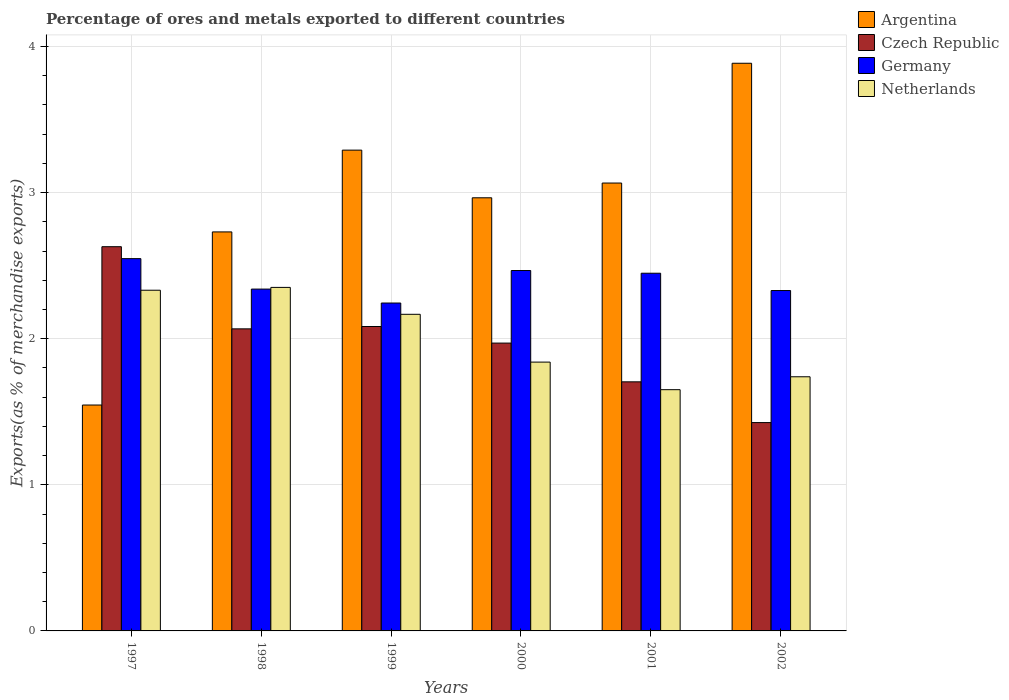How many groups of bars are there?
Give a very brief answer. 6. Are the number of bars on each tick of the X-axis equal?
Offer a very short reply. Yes. How many bars are there on the 5th tick from the right?
Provide a succinct answer. 4. What is the percentage of exports to different countries in Argentina in 2002?
Give a very brief answer. 3.89. Across all years, what is the maximum percentage of exports to different countries in Netherlands?
Your answer should be very brief. 2.35. Across all years, what is the minimum percentage of exports to different countries in Netherlands?
Offer a terse response. 1.65. In which year was the percentage of exports to different countries in Argentina maximum?
Keep it short and to the point. 2002. What is the total percentage of exports to different countries in Netherlands in the graph?
Offer a very short reply. 12.08. What is the difference between the percentage of exports to different countries in Czech Republic in 2000 and that in 2001?
Your response must be concise. 0.27. What is the difference between the percentage of exports to different countries in Argentina in 1997 and the percentage of exports to different countries in Germany in 2002?
Offer a very short reply. -0.78. What is the average percentage of exports to different countries in Argentina per year?
Your answer should be compact. 2.91. In the year 2000, what is the difference between the percentage of exports to different countries in Germany and percentage of exports to different countries in Czech Republic?
Ensure brevity in your answer.  0.5. What is the ratio of the percentage of exports to different countries in Argentina in 1999 to that in 2002?
Provide a short and direct response. 0.85. Is the difference between the percentage of exports to different countries in Germany in 1999 and 2002 greater than the difference between the percentage of exports to different countries in Czech Republic in 1999 and 2002?
Keep it short and to the point. No. What is the difference between the highest and the second highest percentage of exports to different countries in Argentina?
Your answer should be compact. 0.59. What is the difference between the highest and the lowest percentage of exports to different countries in Argentina?
Provide a succinct answer. 2.34. In how many years, is the percentage of exports to different countries in Argentina greater than the average percentage of exports to different countries in Argentina taken over all years?
Offer a terse response. 4. Is the sum of the percentage of exports to different countries in Netherlands in 1999 and 2002 greater than the maximum percentage of exports to different countries in Argentina across all years?
Your response must be concise. Yes. What does the 3rd bar from the left in 1998 represents?
Keep it short and to the point. Germany. What does the 3rd bar from the right in 1999 represents?
Keep it short and to the point. Czech Republic. How many bars are there?
Ensure brevity in your answer.  24. Are the values on the major ticks of Y-axis written in scientific E-notation?
Ensure brevity in your answer.  No. Does the graph contain any zero values?
Keep it short and to the point. No. Does the graph contain grids?
Your response must be concise. Yes. Where does the legend appear in the graph?
Provide a short and direct response. Top right. What is the title of the graph?
Your answer should be compact. Percentage of ores and metals exported to different countries. What is the label or title of the X-axis?
Offer a very short reply. Years. What is the label or title of the Y-axis?
Provide a short and direct response. Exports(as % of merchandise exports). What is the Exports(as % of merchandise exports) of Argentina in 1997?
Your answer should be very brief. 1.55. What is the Exports(as % of merchandise exports) of Czech Republic in 1997?
Give a very brief answer. 2.63. What is the Exports(as % of merchandise exports) in Germany in 1997?
Provide a succinct answer. 2.55. What is the Exports(as % of merchandise exports) in Netherlands in 1997?
Provide a succinct answer. 2.33. What is the Exports(as % of merchandise exports) of Argentina in 1998?
Give a very brief answer. 2.73. What is the Exports(as % of merchandise exports) of Czech Republic in 1998?
Your response must be concise. 2.07. What is the Exports(as % of merchandise exports) of Germany in 1998?
Give a very brief answer. 2.34. What is the Exports(as % of merchandise exports) of Netherlands in 1998?
Keep it short and to the point. 2.35. What is the Exports(as % of merchandise exports) of Argentina in 1999?
Keep it short and to the point. 3.29. What is the Exports(as % of merchandise exports) in Czech Republic in 1999?
Your answer should be compact. 2.08. What is the Exports(as % of merchandise exports) of Germany in 1999?
Give a very brief answer. 2.24. What is the Exports(as % of merchandise exports) of Netherlands in 1999?
Your answer should be very brief. 2.17. What is the Exports(as % of merchandise exports) in Argentina in 2000?
Make the answer very short. 2.96. What is the Exports(as % of merchandise exports) in Czech Republic in 2000?
Make the answer very short. 1.97. What is the Exports(as % of merchandise exports) of Germany in 2000?
Offer a very short reply. 2.47. What is the Exports(as % of merchandise exports) of Netherlands in 2000?
Your response must be concise. 1.84. What is the Exports(as % of merchandise exports) of Argentina in 2001?
Your answer should be compact. 3.07. What is the Exports(as % of merchandise exports) of Czech Republic in 2001?
Your answer should be very brief. 1.7. What is the Exports(as % of merchandise exports) in Germany in 2001?
Ensure brevity in your answer.  2.45. What is the Exports(as % of merchandise exports) in Netherlands in 2001?
Give a very brief answer. 1.65. What is the Exports(as % of merchandise exports) in Argentina in 2002?
Your response must be concise. 3.89. What is the Exports(as % of merchandise exports) in Czech Republic in 2002?
Your answer should be very brief. 1.43. What is the Exports(as % of merchandise exports) of Germany in 2002?
Provide a succinct answer. 2.33. What is the Exports(as % of merchandise exports) in Netherlands in 2002?
Keep it short and to the point. 1.74. Across all years, what is the maximum Exports(as % of merchandise exports) in Argentina?
Provide a succinct answer. 3.89. Across all years, what is the maximum Exports(as % of merchandise exports) of Czech Republic?
Your response must be concise. 2.63. Across all years, what is the maximum Exports(as % of merchandise exports) of Germany?
Provide a short and direct response. 2.55. Across all years, what is the maximum Exports(as % of merchandise exports) of Netherlands?
Provide a short and direct response. 2.35. Across all years, what is the minimum Exports(as % of merchandise exports) in Argentina?
Offer a terse response. 1.55. Across all years, what is the minimum Exports(as % of merchandise exports) of Czech Republic?
Provide a succinct answer. 1.43. Across all years, what is the minimum Exports(as % of merchandise exports) in Germany?
Your answer should be very brief. 2.24. Across all years, what is the minimum Exports(as % of merchandise exports) in Netherlands?
Provide a short and direct response. 1.65. What is the total Exports(as % of merchandise exports) in Argentina in the graph?
Keep it short and to the point. 17.48. What is the total Exports(as % of merchandise exports) of Czech Republic in the graph?
Offer a terse response. 11.88. What is the total Exports(as % of merchandise exports) of Germany in the graph?
Your answer should be compact. 14.38. What is the total Exports(as % of merchandise exports) in Netherlands in the graph?
Make the answer very short. 12.08. What is the difference between the Exports(as % of merchandise exports) in Argentina in 1997 and that in 1998?
Offer a terse response. -1.18. What is the difference between the Exports(as % of merchandise exports) in Czech Republic in 1997 and that in 1998?
Keep it short and to the point. 0.56. What is the difference between the Exports(as % of merchandise exports) of Germany in 1997 and that in 1998?
Your answer should be very brief. 0.21. What is the difference between the Exports(as % of merchandise exports) of Netherlands in 1997 and that in 1998?
Give a very brief answer. -0.02. What is the difference between the Exports(as % of merchandise exports) in Argentina in 1997 and that in 1999?
Make the answer very short. -1.74. What is the difference between the Exports(as % of merchandise exports) in Czech Republic in 1997 and that in 1999?
Your response must be concise. 0.55. What is the difference between the Exports(as % of merchandise exports) of Germany in 1997 and that in 1999?
Your response must be concise. 0.3. What is the difference between the Exports(as % of merchandise exports) of Netherlands in 1997 and that in 1999?
Give a very brief answer. 0.16. What is the difference between the Exports(as % of merchandise exports) of Argentina in 1997 and that in 2000?
Keep it short and to the point. -1.42. What is the difference between the Exports(as % of merchandise exports) of Czech Republic in 1997 and that in 2000?
Your answer should be compact. 0.66. What is the difference between the Exports(as % of merchandise exports) in Germany in 1997 and that in 2000?
Give a very brief answer. 0.08. What is the difference between the Exports(as % of merchandise exports) of Netherlands in 1997 and that in 2000?
Ensure brevity in your answer.  0.49. What is the difference between the Exports(as % of merchandise exports) in Argentina in 1997 and that in 2001?
Give a very brief answer. -1.52. What is the difference between the Exports(as % of merchandise exports) in Czech Republic in 1997 and that in 2001?
Ensure brevity in your answer.  0.92. What is the difference between the Exports(as % of merchandise exports) of Germany in 1997 and that in 2001?
Your answer should be compact. 0.1. What is the difference between the Exports(as % of merchandise exports) of Netherlands in 1997 and that in 2001?
Give a very brief answer. 0.68. What is the difference between the Exports(as % of merchandise exports) of Argentina in 1997 and that in 2002?
Offer a very short reply. -2.34. What is the difference between the Exports(as % of merchandise exports) in Czech Republic in 1997 and that in 2002?
Ensure brevity in your answer.  1.2. What is the difference between the Exports(as % of merchandise exports) of Germany in 1997 and that in 2002?
Make the answer very short. 0.22. What is the difference between the Exports(as % of merchandise exports) in Netherlands in 1997 and that in 2002?
Keep it short and to the point. 0.59. What is the difference between the Exports(as % of merchandise exports) of Argentina in 1998 and that in 1999?
Offer a very short reply. -0.56. What is the difference between the Exports(as % of merchandise exports) in Czech Republic in 1998 and that in 1999?
Your answer should be compact. -0.02. What is the difference between the Exports(as % of merchandise exports) of Germany in 1998 and that in 1999?
Keep it short and to the point. 0.1. What is the difference between the Exports(as % of merchandise exports) of Netherlands in 1998 and that in 1999?
Provide a succinct answer. 0.18. What is the difference between the Exports(as % of merchandise exports) in Argentina in 1998 and that in 2000?
Provide a short and direct response. -0.23. What is the difference between the Exports(as % of merchandise exports) of Czech Republic in 1998 and that in 2000?
Your answer should be compact. 0.1. What is the difference between the Exports(as % of merchandise exports) in Germany in 1998 and that in 2000?
Provide a succinct answer. -0.13. What is the difference between the Exports(as % of merchandise exports) in Netherlands in 1998 and that in 2000?
Offer a terse response. 0.51. What is the difference between the Exports(as % of merchandise exports) of Argentina in 1998 and that in 2001?
Ensure brevity in your answer.  -0.33. What is the difference between the Exports(as % of merchandise exports) of Czech Republic in 1998 and that in 2001?
Provide a short and direct response. 0.36. What is the difference between the Exports(as % of merchandise exports) in Germany in 1998 and that in 2001?
Ensure brevity in your answer.  -0.11. What is the difference between the Exports(as % of merchandise exports) of Netherlands in 1998 and that in 2001?
Provide a short and direct response. 0.7. What is the difference between the Exports(as % of merchandise exports) in Argentina in 1998 and that in 2002?
Keep it short and to the point. -1.15. What is the difference between the Exports(as % of merchandise exports) in Czech Republic in 1998 and that in 2002?
Ensure brevity in your answer.  0.64. What is the difference between the Exports(as % of merchandise exports) of Germany in 1998 and that in 2002?
Keep it short and to the point. 0.01. What is the difference between the Exports(as % of merchandise exports) in Netherlands in 1998 and that in 2002?
Provide a succinct answer. 0.61. What is the difference between the Exports(as % of merchandise exports) of Argentina in 1999 and that in 2000?
Provide a short and direct response. 0.33. What is the difference between the Exports(as % of merchandise exports) in Czech Republic in 1999 and that in 2000?
Ensure brevity in your answer.  0.11. What is the difference between the Exports(as % of merchandise exports) in Germany in 1999 and that in 2000?
Offer a terse response. -0.22. What is the difference between the Exports(as % of merchandise exports) of Netherlands in 1999 and that in 2000?
Your response must be concise. 0.33. What is the difference between the Exports(as % of merchandise exports) in Argentina in 1999 and that in 2001?
Offer a very short reply. 0.23. What is the difference between the Exports(as % of merchandise exports) in Czech Republic in 1999 and that in 2001?
Give a very brief answer. 0.38. What is the difference between the Exports(as % of merchandise exports) of Germany in 1999 and that in 2001?
Give a very brief answer. -0.2. What is the difference between the Exports(as % of merchandise exports) in Netherlands in 1999 and that in 2001?
Provide a short and direct response. 0.52. What is the difference between the Exports(as % of merchandise exports) in Argentina in 1999 and that in 2002?
Give a very brief answer. -0.59. What is the difference between the Exports(as % of merchandise exports) of Czech Republic in 1999 and that in 2002?
Offer a very short reply. 0.66. What is the difference between the Exports(as % of merchandise exports) of Germany in 1999 and that in 2002?
Your answer should be compact. -0.09. What is the difference between the Exports(as % of merchandise exports) of Netherlands in 1999 and that in 2002?
Keep it short and to the point. 0.43. What is the difference between the Exports(as % of merchandise exports) in Argentina in 2000 and that in 2001?
Your answer should be very brief. -0.1. What is the difference between the Exports(as % of merchandise exports) of Czech Republic in 2000 and that in 2001?
Ensure brevity in your answer.  0.27. What is the difference between the Exports(as % of merchandise exports) of Germany in 2000 and that in 2001?
Ensure brevity in your answer.  0.02. What is the difference between the Exports(as % of merchandise exports) of Netherlands in 2000 and that in 2001?
Offer a very short reply. 0.19. What is the difference between the Exports(as % of merchandise exports) of Argentina in 2000 and that in 2002?
Ensure brevity in your answer.  -0.92. What is the difference between the Exports(as % of merchandise exports) of Czech Republic in 2000 and that in 2002?
Give a very brief answer. 0.54. What is the difference between the Exports(as % of merchandise exports) in Germany in 2000 and that in 2002?
Keep it short and to the point. 0.14. What is the difference between the Exports(as % of merchandise exports) of Netherlands in 2000 and that in 2002?
Give a very brief answer. 0.1. What is the difference between the Exports(as % of merchandise exports) of Argentina in 2001 and that in 2002?
Your answer should be very brief. -0.82. What is the difference between the Exports(as % of merchandise exports) in Czech Republic in 2001 and that in 2002?
Your answer should be very brief. 0.28. What is the difference between the Exports(as % of merchandise exports) in Germany in 2001 and that in 2002?
Provide a short and direct response. 0.12. What is the difference between the Exports(as % of merchandise exports) of Netherlands in 2001 and that in 2002?
Make the answer very short. -0.09. What is the difference between the Exports(as % of merchandise exports) of Argentina in 1997 and the Exports(as % of merchandise exports) of Czech Republic in 1998?
Your answer should be very brief. -0.52. What is the difference between the Exports(as % of merchandise exports) in Argentina in 1997 and the Exports(as % of merchandise exports) in Germany in 1998?
Ensure brevity in your answer.  -0.79. What is the difference between the Exports(as % of merchandise exports) of Argentina in 1997 and the Exports(as % of merchandise exports) of Netherlands in 1998?
Give a very brief answer. -0.81. What is the difference between the Exports(as % of merchandise exports) in Czech Republic in 1997 and the Exports(as % of merchandise exports) in Germany in 1998?
Ensure brevity in your answer.  0.29. What is the difference between the Exports(as % of merchandise exports) of Czech Republic in 1997 and the Exports(as % of merchandise exports) of Netherlands in 1998?
Provide a short and direct response. 0.28. What is the difference between the Exports(as % of merchandise exports) in Germany in 1997 and the Exports(as % of merchandise exports) in Netherlands in 1998?
Your answer should be very brief. 0.2. What is the difference between the Exports(as % of merchandise exports) of Argentina in 1997 and the Exports(as % of merchandise exports) of Czech Republic in 1999?
Provide a short and direct response. -0.54. What is the difference between the Exports(as % of merchandise exports) in Argentina in 1997 and the Exports(as % of merchandise exports) in Germany in 1999?
Give a very brief answer. -0.7. What is the difference between the Exports(as % of merchandise exports) of Argentina in 1997 and the Exports(as % of merchandise exports) of Netherlands in 1999?
Offer a terse response. -0.62. What is the difference between the Exports(as % of merchandise exports) of Czech Republic in 1997 and the Exports(as % of merchandise exports) of Germany in 1999?
Provide a succinct answer. 0.39. What is the difference between the Exports(as % of merchandise exports) of Czech Republic in 1997 and the Exports(as % of merchandise exports) of Netherlands in 1999?
Keep it short and to the point. 0.46. What is the difference between the Exports(as % of merchandise exports) of Germany in 1997 and the Exports(as % of merchandise exports) of Netherlands in 1999?
Your answer should be very brief. 0.38. What is the difference between the Exports(as % of merchandise exports) of Argentina in 1997 and the Exports(as % of merchandise exports) of Czech Republic in 2000?
Provide a succinct answer. -0.42. What is the difference between the Exports(as % of merchandise exports) of Argentina in 1997 and the Exports(as % of merchandise exports) of Germany in 2000?
Your response must be concise. -0.92. What is the difference between the Exports(as % of merchandise exports) in Argentina in 1997 and the Exports(as % of merchandise exports) in Netherlands in 2000?
Ensure brevity in your answer.  -0.29. What is the difference between the Exports(as % of merchandise exports) in Czech Republic in 1997 and the Exports(as % of merchandise exports) in Germany in 2000?
Your answer should be very brief. 0.16. What is the difference between the Exports(as % of merchandise exports) in Czech Republic in 1997 and the Exports(as % of merchandise exports) in Netherlands in 2000?
Provide a short and direct response. 0.79. What is the difference between the Exports(as % of merchandise exports) of Germany in 1997 and the Exports(as % of merchandise exports) of Netherlands in 2000?
Keep it short and to the point. 0.71. What is the difference between the Exports(as % of merchandise exports) in Argentina in 1997 and the Exports(as % of merchandise exports) in Czech Republic in 2001?
Provide a short and direct response. -0.16. What is the difference between the Exports(as % of merchandise exports) in Argentina in 1997 and the Exports(as % of merchandise exports) in Germany in 2001?
Give a very brief answer. -0.9. What is the difference between the Exports(as % of merchandise exports) in Argentina in 1997 and the Exports(as % of merchandise exports) in Netherlands in 2001?
Offer a terse response. -0.1. What is the difference between the Exports(as % of merchandise exports) of Czech Republic in 1997 and the Exports(as % of merchandise exports) of Germany in 2001?
Ensure brevity in your answer.  0.18. What is the difference between the Exports(as % of merchandise exports) of Czech Republic in 1997 and the Exports(as % of merchandise exports) of Netherlands in 2001?
Provide a short and direct response. 0.98. What is the difference between the Exports(as % of merchandise exports) in Germany in 1997 and the Exports(as % of merchandise exports) in Netherlands in 2001?
Your answer should be compact. 0.9. What is the difference between the Exports(as % of merchandise exports) of Argentina in 1997 and the Exports(as % of merchandise exports) of Czech Republic in 2002?
Your answer should be very brief. 0.12. What is the difference between the Exports(as % of merchandise exports) of Argentina in 1997 and the Exports(as % of merchandise exports) of Germany in 2002?
Provide a succinct answer. -0.78. What is the difference between the Exports(as % of merchandise exports) of Argentina in 1997 and the Exports(as % of merchandise exports) of Netherlands in 2002?
Keep it short and to the point. -0.19. What is the difference between the Exports(as % of merchandise exports) in Czech Republic in 1997 and the Exports(as % of merchandise exports) in Germany in 2002?
Your response must be concise. 0.3. What is the difference between the Exports(as % of merchandise exports) of Czech Republic in 1997 and the Exports(as % of merchandise exports) of Netherlands in 2002?
Ensure brevity in your answer.  0.89. What is the difference between the Exports(as % of merchandise exports) in Germany in 1997 and the Exports(as % of merchandise exports) in Netherlands in 2002?
Your response must be concise. 0.81. What is the difference between the Exports(as % of merchandise exports) in Argentina in 1998 and the Exports(as % of merchandise exports) in Czech Republic in 1999?
Offer a terse response. 0.65. What is the difference between the Exports(as % of merchandise exports) of Argentina in 1998 and the Exports(as % of merchandise exports) of Germany in 1999?
Keep it short and to the point. 0.49. What is the difference between the Exports(as % of merchandise exports) in Argentina in 1998 and the Exports(as % of merchandise exports) in Netherlands in 1999?
Your answer should be compact. 0.56. What is the difference between the Exports(as % of merchandise exports) of Czech Republic in 1998 and the Exports(as % of merchandise exports) of Germany in 1999?
Make the answer very short. -0.18. What is the difference between the Exports(as % of merchandise exports) in Czech Republic in 1998 and the Exports(as % of merchandise exports) in Netherlands in 1999?
Give a very brief answer. -0.1. What is the difference between the Exports(as % of merchandise exports) in Germany in 1998 and the Exports(as % of merchandise exports) in Netherlands in 1999?
Offer a very short reply. 0.17. What is the difference between the Exports(as % of merchandise exports) of Argentina in 1998 and the Exports(as % of merchandise exports) of Czech Republic in 2000?
Make the answer very short. 0.76. What is the difference between the Exports(as % of merchandise exports) of Argentina in 1998 and the Exports(as % of merchandise exports) of Germany in 2000?
Make the answer very short. 0.26. What is the difference between the Exports(as % of merchandise exports) in Argentina in 1998 and the Exports(as % of merchandise exports) in Netherlands in 2000?
Offer a very short reply. 0.89. What is the difference between the Exports(as % of merchandise exports) of Czech Republic in 1998 and the Exports(as % of merchandise exports) of Germany in 2000?
Offer a terse response. -0.4. What is the difference between the Exports(as % of merchandise exports) in Czech Republic in 1998 and the Exports(as % of merchandise exports) in Netherlands in 2000?
Offer a very short reply. 0.23. What is the difference between the Exports(as % of merchandise exports) of Germany in 1998 and the Exports(as % of merchandise exports) of Netherlands in 2000?
Keep it short and to the point. 0.5. What is the difference between the Exports(as % of merchandise exports) in Argentina in 1998 and the Exports(as % of merchandise exports) in Czech Republic in 2001?
Ensure brevity in your answer.  1.03. What is the difference between the Exports(as % of merchandise exports) of Argentina in 1998 and the Exports(as % of merchandise exports) of Germany in 2001?
Ensure brevity in your answer.  0.28. What is the difference between the Exports(as % of merchandise exports) in Argentina in 1998 and the Exports(as % of merchandise exports) in Netherlands in 2001?
Keep it short and to the point. 1.08. What is the difference between the Exports(as % of merchandise exports) in Czech Republic in 1998 and the Exports(as % of merchandise exports) in Germany in 2001?
Make the answer very short. -0.38. What is the difference between the Exports(as % of merchandise exports) of Czech Republic in 1998 and the Exports(as % of merchandise exports) of Netherlands in 2001?
Offer a very short reply. 0.42. What is the difference between the Exports(as % of merchandise exports) in Germany in 1998 and the Exports(as % of merchandise exports) in Netherlands in 2001?
Make the answer very short. 0.69. What is the difference between the Exports(as % of merchandise exports) of Argentina in 1998 and the Exports(as % of merchandise exports) of Czech Republic in 2002?
Your response must be concise. 1.31. What is the difference between the Exports(as % of merchandise exports) of Argentina in 1998 and the Exports(as % of merchandise exports) of Germany in 2002?
Ensure brevity in your answer.  0.4. What is the difference between the Exports(as % of merchandise exports) of Argentina in 1998 and the Exports(as % of merchandise exports) of Netherlands in 2002?
Your answer should be compact. 0.99. What is the difference between the Exports(as % of merchandise exports) in Czech Republic in 1998 and the Exports(as % of merchandise exports) in Germany in 2002?
Ensure brevity in your answer.  -0.26. What is the difference between the Exports(as % of merchandise exports) of Czech Republic in 1998 and the Exports(as % of merchandise exports) of Netherlands in 2002?
Offer a terse response. 0.33. What is the difference between the Exports(as % of merchandise exports) of Germany in 1998 and the Exports(as % of merchandise exports) of Netherlands in 2002?
Offer a very short reply. 0.6. What is the difference between the Exports(as % of merchandise exports) in Argentina in 1999 and the Exports(as % of merchandise exports) in Czech Republic in 2000?
Make the answer very short. 1.32. What is the difference between the Exports(as % of merchandise exports) in Argentina in 1999 and the Exports(as % of merchandise exports) in Germany in 2000?
Ensure brevity in your answer.  0.82. What is the difference between the Exports(as % of merchandise exports) in Argentina in 1999 and the Exports(as % of merchandise exports) in Netherlands in 2000?
Keep it short and to the point. 1.45. What is the difference between the Exports(as % of merchandise exports) of Czech Republic in 1999 and the Exports(as % of merchandise exports) of Germany in 2000?
Offer a very short reply. -0.38. What is the difference between the Exports(as % of merchandise exports) of Czech Republic in 1999 and the Exports(as % of merchandise exports) of Netherlands in 2000?
Provide a succinct answer. 0.24. What is the difference between the Exports(as % of merchandise exports) of Germany in 1999 and the Exports(as % of merchandise exports) of Netherlands in 2000?
Make the answer very short. 0.4. What is the difference between the Exports(as % of merchandise exports) of Argentina in 1999 and the Exports(as % of merchandise exports) of Czech Republic in 2001?
Offer a very short reply. 1.59. What is the difference between the Exports(as % of merchandise exports) in Argentina in 1999 and the Exports(as % of merchandise exports) in Germany in 2001?
Keep it short and to the point. 0.84. What is the difference between the Exports(as % of merchandise exports) of Argentina in 1999 and the Exports(as % of merchandise exports) of Netherlands in 2001?
Offer a very short reply. 1.64. What is the difference between the Exports(as % of merchandise exports) in Czech Republic in 1999 and the Exports(as % of merchandise exports) in Germany in 2001?
Offer a terse response. -0.36. What is the difference between the Exports(as % of merchandise exports) of Czech Republic in 1999 and the Exports(as % of merchandise exports) of Netherlands in 2001?
Provide a short and direct response. 0.43. What is the difference between the Exports(as % of merchandise exports) in Germany in 1999 and the Exports(as % of merchandise exports) in Netherlands in 2001?
Your answer should be very brief. 0.59. What is the difference between the Exports(as % of merchandise exports) of Argentina in 1999 and the Exports(as % of merchandise exports) of Czech Republic in 2002?
Give a very brief answer. 1.86. What is the difference between the Exports(as % of merchandise exports) in Argentina in 1999 and the Exports(as % of merchandise exports) in Germany in 2002?
Your response must be concise. 0.96. What is the difference between the Exports(as % of merchandise exports) of Argentina in 1999 and the Exports(as % of merchandise exports) of Netherlands in 2002?
Your answer should be compact. 1.55. What is the difference between the Exports(as % of merchandise exports) of Czech Republic in 1999 and the Exports(as % of merchandise exports) of Germany in 2002?
Offer a terse response. -0.25. What is the difference between the Exports(as % of merchandise exports) in Czech Republic in 1999 and the Exports(as % of merchandise exports) in Netherlands in 2002?
Your response must be concise. 0.34. What is the difference between the Exports(as % of merchandise exports) of Germany in 1999 and the Exports(as % of merchandise exports) of Netherlands in 2002?
Offer a very short reply. 0.5. What is the difference between the Exports(as % of merchandise exports) in Argentina in 2000 and the Exports(as % of merchandise exports) in Czech Republic in 2001?
Ensure brevity in your answer.  1.26. What is the difference between the Exports(as % of merchandise exports) in Argentina in 2000 and the Exports(as % of merchandise exports) in Germany in 2001?
Provide a succinct answer. 0.52. What is the difference between the Exports(as % of merchandise exports) of Argentina in 2000 and the Exports(as % of merchandise exports) of Netherlands in 2001?
Provide a succinct answer. 1.31. What is the difference between the Exports(as % of merchandise exports) in Czech Republic in 2000 and the Exports(as % of merchandise exports) in Germany in 2001?
Make the answer very short. -0.48. What is the difference between the Exports(as % of merchandise exports) of Czech Republic in 2000 and the Exports(as % of merchandise exports) of Netherlands in 2001?
Your answer should be very brief. 0.32. What is the difference between the Exports(as % of merchandise exports) in Germany in 2000 and the Exports(as % of merchandise exports) in Netherlands in 2001?
Your answer should be very brief. 0.82. What is the difference between the Exports(as % of merchandise exports) of Argentina in 2000 and the Exports(as % of merchandise exports) of Czech Republic in 2002?
Provide a succinct answer. 1.54. What is the difference between the Exports(as % of merchandise exports) of Argentina in 2000 and the Exports(as % of merchandise exports) of Germany in 2002?
Your response must be concise. 0.63. What is the difference between the Exports(as % of merchandise exports) of Argentina in 2000 and the Exports(as % of merchandise exports) of Netherlands in 2002?
Offer a very short reply. 1.23. What is the difference between the Exports(as % of merchandise exports) of Czech Republic in 2000 and the Exports(as % of merchandise exports) of Germany in 2002?
Your answer should be compact. -0.36. What is the difference between the Exports(as % of merchandise exports) in Czech Republic in 2000 and the Exports(as % of merchandise exports) in Netherlands in 2002?
Make the answer very short. 0.23. What is the difference between the Exports(as % of merchandise exports) of Germany in 2000 and the Exports(as % of merchandise exports) of Netherlands in 2002?
Ensure brevity in your answer.  0.73. What is the difference between the Exports(as % of merchandise exports) in Argentina in 2001 and the Exports(as % of merchandise exports) in Czech Republic in 2002?
Make the answer very short. 1.64. What is the difference between the Exports(as % of merchandise exports) of Argentina in 2001 and the Exports(as % of merchandise exports) of Germany in 2002?
Make the answer very short. 0.74. What is the difference between the Exports(as % of merchandise exports) in Argentina in 2001 and the Exports(as % of merchandise exports) in Netherlands in 2002?
Ensure brevity in your answer.  1.33. What is the difference between the Exports(as % of merchandise exports) of Czech Republic in 2001 and the Exports(as % of merchandise exports) of Germany in 2002?
Give a very brief answer. -0.62. What is the difference between the Exports(as % of merchandise exports) of Czech Republic in 2001 and the Exports(as % of merchandise exports) of Netherlands in 2002?
Offer a very short reply. -0.03. What is the difference between the Exports(as % of merchandise exports) in Germany in 2001 and the Exports(as % of merchandise exports) in Netherlands in 2002?
Give a very brief answer. 0.71. What is the average Exports(as % of merchandise exports) in Argentina per year?
Your response must be concise. 2.91. What is the average Exports(as % of merchandise exports) of Czech Republic per year?
Your response must be concise. 1.98. What is the average Exports(as % of merchandise exports) of Germany per year?
Keep it short and to the point. 2.4. What is the average Exports(as % of merchandise exports) of Netherlands per year?
Your answer should be compact. 2.01. In the year 1997, what is the difference between the Exports(as % of merchandise exports) in Argentina and Exports(as % of merchandise exports) in Czech Republic?
Offer a terse response. -1.08. In the year 1997, what is the difference between the Exports(as % of merchandise exports) in Argentina and Exports(as % of merchandise exports) in Germany?
Keep it short and to the point. -1. In the year 1997, what is the difference between the Exports(as % of merchandise exports) of Argentina and Exports(as % of merchandise exports) of Netherlands?
Make the answer very short. -0.79. In the year 1997, what is the difference between the Exports(as % of merchandise exports) in Czech Republic and Exports(as % of merchandise exports) in Germany?
Ensure brevity in your answer.  0.08. In the year 1997, what is the difference between the Exports(as % of merchandise exports) in Czech Republic and Exports(as % of merchandise exports) in Netherlands?
Your response must be concise. 0.3. In the year 1997, what is the difference between the Exports(as % of merchandise exports) in Germany and Exports(as % of merchandise exports) in Netherlands?
Offer a very short reply. 0.22. In the year 1998, what is the difference between the Exports(as % of merchandise exports) of Argentina and Exports(as % of merchandise exports) of Czech Republic?
Give a very brief answer. 0.66. In the year 1998, what is the difference between the Exports(as % of merchandise exports) of Argentina and Exports(as % of merchandise exports) of Germany?
Provide a short and direct response. 0.39. In the year 1998, what is the difference between the Exports(as % of merchandise exports) of Argentina and Exports(as % of merchandise exports) of Netherlands?
Ensure brevity in your answer.  0.38. In the year 1998, what is the difference between the Exports(as % of merchandise exports) in Czech Republic and Exports(as % of merchandise exports) in Germany?
Keep it short and to the point. -0.27. In the year 1998, what is the difference between the Exports(as % of merchandise exports) in Czech Republic and Exports(as % of merchandise exports) in Netherlands?
Your answer should be very brief. -0.28. In the year 1998, what is the difference between the Exports(as % of merchandise exports) of Germany and Exports(as % of merchandise exports) of Netherlands?
Make the answer very short. -0.01. In the year 1999, what is the difference between the Exports(as % of merchandise exports) of Argentina and Exports(as % of merchandise exports) of Czech Republic?
Your answer should be compact. 1.21. In the year 1999, what is the difference between the Exports(as % of merchandise exports) in Argentina and Exports(as % of merchandise exports) in Germany?
Your answer should be compact. 1.05. In the year 1999, what is the difference between the Exports(as % of merchandise exports) in Argentina and Exports(as % of merchandise exports) in Netherlands?
Ensure brevity in your answer.  1.12. In the year 1999, what is the difference between the Exports(as % of merchandise exports) in Czech Republic and Exports(as % of merchandise exports) in Germany?
Provide a short and direct response. -0.16. In the year 1999, what is the difference between the Exports(as % of merchandise exports) in Czech Republic and Exports(as % of merchandise exports) in Netherlands?
Make the answer very short. -0.08. In the year 1999, what is the difference between the Exports(as % of merchandise exports) in Germany and Exports(as % of merchandise exports) in Netherlands?
Your answer should be very brief. 0.08. In the year 2000, what is the difference between the Exports(as % of merchandise exports) in Argentina and Exports(as % of merchandise exports) in Germany?
Your answer should be compact. 0.5. In the year 2000, what is the difference between the Exports(as % of merchandise exports) in Argentina and Exports(as % of merchandise exports) in Netherlands?
Provide a short and direct response. 1.12. In the year 2000, what is the difference between the Exports(as % of merchandise exports) of Czech Republic and Exports(as % of merchandise exports) of Germany?
Make the answer very short. -0.5. In the year 2000, what is the difference between the Exports(as % of merchandise exports) in Czech Republic and Exports(as % of merchandise exports) in Netherlands?
Give a very brief answer. 0.13. In the year 2000, what is the difference between the Exports(as % of merchandise exports) of Germany and Exports(as % of merchandise exports) of Netherlands?
Offer a terse response. 0.63. In the year 2001, what is the difference between the Exports(as % of merchandise exports) in Argentina and Exports(as % of merchandise exports) in Czech Republic?
Provide a succinct answer. 1.36. In the year 2001, what is the difference between the Exports(as % of merchandise exports) in Argentina and Exports(as % of merchandise exports) in Germany?
Offer a very short reply. 0.62. In the year 2001, what is the difference between the Exports(as % of merchandise exports) of Argentina and Exports(as % of merchandise exports) of Netherlands?
Make the answer very short. 1.41. In the year 2001, what is the difference between the Exports(as % of merchandise exports) of Czech Republic and Exports(as % of merchandise exports) of Germany?
Give a very brief answer. -0.74. In the year 2001, what is the difference between the Exports(as % of merchandise exports) in Czech Republic and Exports(as % of merchandise exports) in Netherlands?
Ensure brevity in your answer.  0.05. In the year 2001, what is the difference between the Exports(as % of merchandise exports) in Germany and Exports(as % of merchandise exports) in Netherlands?
Offer a very short reply. 0.8. In the year 2002, what is the difference between the Exports(as % of merchandise exports) in Argentina and Exports(as % of merchandise exports) in Czech Republic?
Offer a very short reply. 2.46. In the year 2002, what is the difference between the Exports(as % of merchandise exports) of Argentina and Exports(as % of merchandise exports) of Germany?
Your answer should be compact. 1.56. In the year 2002, what is the difference between the Exports(as % of merchandise exports) of Argentina and Exports(as % of merchandise exports) of Netherlands?
Make the answer very short. 2.15. In the year 2002, what is the difference between the Exports(as % of merchandise exports) of Czech Republic and Exports(as % of merchandise exports) of Germany?
Give a very brief answer. -0.9. In the year 2002, what is the difference between the Exports(as % of merchandise exports) in Czech Republic and Exports(as % of merchandise exports) in Netherlands?
Give a very brief answer. -0.31. In the year 2002, what is the difference between the Exports(as % of merchandise exports) of Germany and Exports(as % of merchandise exports) of Netherlands?
Offer a terse response. 0.59. What is the ratio of the Exports(as % of merchandise exports) of Argentina in 1997 to that in 1998?
Ensure brevity in your answer.  0.57. What is the ratio of the Exports(as % of merchandise exports) of Czech Republic in 1997 to that in 1998?
Give a very brief answer. 1.27. What is the ratio of the Exports(as % of merchandise exports) of Germany in 1997 to that in 1998?
Provide a short and direct response. 1.09. What is the ratio of the Exports(as % of merchandise exports) of Netherlands in 1997 to that in 1998?
Provide a short and direct response. 0.99. What is the ratio of the Exports(as % of merchandise exports) of Argentina in 1997 to that in 1999?
Your answer should be compact. 0.47. What is the ratio of the Exports(as % of merchandise exports) in Czech Republic in 1997 to that in 1999?
Provide a succinct answer. 1.26. What is the ratio of the Exports(as % of merchandise exports) of Germany in 1997 to that in 1999?
Offer a very short reply. 1.14. What is the ratio of the Exports(as % of merchandise exports) of Netherlands in 1997 to that in 1999?
Ensure brevity in your answer.  1.08. What is the ratio of the Exports(as % of merchandise exports) in Argentina in 1997 to that in 2000?
Your answer should be very brief. 0.52. What is the ratio of the Exports(as % of merchandise exports) of Czech Republic in 1997 to that in 2000?
Give a very brief answer. 1.33. What is the ratio of the Exports(as % of merchandise exports) in Germany in 1997 to that in 2000?
Provide a succinct answer. 1.03. What is the ratio of the Exports(as % of merchandise exports) of Netherlands in 1997 to that in 2000?
Your response must be concise. 1.27. What is the ratio of the Exports(as % of merchandise exports) of Argentina in 1997 to that in 2001?
Provide a short and direct response. 0.5. What is the ratio of the Exports(as % of merchandise exports) in Czech Republic in 1997 to that in 2001?
Your answer should be very brief. 1.54. What is the ratio of the Exports(as % of merchandise exports) in Germany in 1997 to that in 2001?
Make the answer very short. 1.04. What is the ratio of the Exports(as % of merchandise exports) of Netherlands in 1997 to that in 2001?
Your answer should be compact. 1.41. What is the ratio of the Exports(as % of merchandise exports) of Argentina in 1997 to that in 2002?
Make the answer very short. 0.4. What is the ratio of the Exports(as % of merchandise exports) of Czech Republic in 1997 to that in 2002?
Offer a terse response. 1.84. What is the ratio of the Exports(as % of merchandise exports) in Germany in 1997 to that in 2002?
Provide a succinct answer. 1.09. What is the ratio of the Exports(as % of merchandise exports) of Netherlands in 1997 to that in 2002?
Your response must be concise. 1.34. What is the ratio of the Exports(as % of merchandise exports) of Argentina in 1998 to that in 1999?
Offer a terse response. 0.83. What is the ratio of the Exports(as % of merchandise exports) of Germany in 1998 to that in 1999?
Make the answer very short. 1.04. What is the ratio of the Exports(as % of merchandise exports) of Netherlands in 1998 to that in 1999?
Offer a very short reply. 1.08. What is the ratio of the Exports(as % of merchandise exports) in Argentina in 1998 to that in 2000?
Make the answer very short. 0.92. What is the ratio of the Exports(as % of merchandise exports) in Czech Republic in 1998 to that in 2000?
Give a very brief answer. 1.05. What is the ratio of the Exports(as % of merchandise exports) in Germany in 1998 to that in 2000?
Your answer should be compact. 0.95. What is the ratio of the Exports(as % of merchandise exports) in Netherlands in 1998 to that in 2000?
Offer a terse response. 1.28. What is the ratio of the Exports(as % of merchandise exports) in Argentina in 1998 to that in 2001?
Your answer should be very brief. 0.89. What is the ratio of the Exports(as % of merchandise exports) in Czech Republic in 1998 to that in 2001?
Offer a very short reply. 1.21. What is the ratio of the Exports(as % of merchandise exports) in Germany in 1998 to that in 2001?
Make the answer very short. 0.96. What is the ratio of the Exports(as % of merchandise exports) in Netherlands in 1998 to that in 2001?
Provide a short and direct response. 1.42. What is the ratio of the Exports(as % of merchandise exports) in Argentina in 1998 to that in 2002?
Give a very brief answer. 0.7. What is the ratio of the Exports(as % of merchandise exports) of Czech Republic in 1998 to that in 2002?
Your answer should be compact. 1.45. What is the ratio of the Exports(as % of merchandise exports) in Germany in 1998 to that in 2002?
Your response must be concise. 1. What is the ratio of the Exports(as % of merchandise exports) of Netherlands in 1998 to that in 2002?
Offer a very short reply. 1.35. What is the ratio of the Exports(as % of merchandise exports) in Argentina in 1999 to that in 2000?
Your answer should be very brief. 1.11. What is the ratio of the Exports(as % of merchandise exports) of Czech Republic in 1999 to that in 2000?
Ensure brevity in your answer.  1.06. What is the ratio of the Exports(as % of merchandise exports) of Germany in 1999 to that in 2000?
Provide a succinct answer. 0.91. What is the ratio of the Exports(as % of merchandise exports) in Netherlands in 1999 to that in 2000?
Keep it short and to the point. 1.18. What is the ratio of the Exports(as % of merchandise exports) in Argentina in 1999 to that in 2001?
Your response must be concise. 1.07. What is the ratio of the Exports(as % of merchandise exports) of Czech Republic in 1999 to that in 2001?
Offer a very short reply. 1.22. What is the ratio of the Exports(as % of merchandise exports) in Germany in 1999 to that in 2001?
Your response must be concise. 0.92. What is the ratio of the Exports(as % of merchandise exports) of Netherlands in 1999 to that in 2001?
Provide a succinct answer. 1.31. What is the ratio of the Exports(as % of merchandise exports) of Argentina in 1999 to that in 2002?
Provide a short and direct response. 0.85. What is the ratio of the Exports(as % of merchandise exports) in Czech Republic in 1999 to that in 2002?
Provide a succinct answer. 1.46. What is the ratio of the Exports(as % of merchandise exports) in Germany in 1999 to that in 2002?
Make the answer very short. 0.96. What is the ratio of the Exports(as % of merchandise exports) of Netherlands in 1999 to that in 2002?
Ensure brevity in your answer.  1.25. What is the ratio of the Exports(as % of merchandise exports) of Argentina in 2000 to that in 2001?
Keep it short and to the point. 0.97. What is the ratio of the Exports(as % of merchandise exports) in Czech Republic in 2000 to that in 2001?
Your answer should be compact. 1.16. What is the ratio of the Exports(as % of merchandise exports) of Germany in 2000 to that in 2001?
Your response must be concise. 1.01. What is the ratio of the Exports(as % of merchandise exports) in Netherlands in 2000 to that in 2001?
Make the answer very short. 1.11. What is the ratio of the Exports(as % of merchandise exports) of Argentina in 2000 to that in 2002?
Offer a terse response. 0.76. What is the ratio of the Exports(as % of merchandise exports) of Czech Republic in 2000 to that in 2002?
Provide a succinct answer. 1.38. What is the ratio of the Exports(as % of merchandise exports) of Germany in 2000 to that in 2002?
Provide a succinct answer. 1.06. What is the ratio of the Exports(as % of merchandise exports) of Netherlands in 2000 to that in 2002?
Give a very brief answer. 1.06. What is the ratio of the Exports(as % of merchandise exports) in Argentina in 2001 to that in 2002?
Provide a succinct answer. 0.79. What is the ratio of the Exports(as % of merchandise exports) in Czech Republic in 2001 to that in 2002?
Offer a very short reply. 1.2. What is the ratio of the Exports(as % of merchandise exports) of Germany in 2001 to that in 2002?
Your answer should be compact. 1.05. What is the ratio of the Exports(as % of merchandise exports) in Netherlands in 2001 to that in 2002?
Ensure brevity in your answer.  0.95. What is the difference between the highest and the second highest Exports(as % of merchandise exports) of Argentina?
Offer a terse response. 0.59. What is the difference between the highest and the second highest Exports(as % of merchandise exports) of Czech Republic?
Provide a succinct answer. 0.55. What is the difference between the highest and the second highest Exports(as % of merchandise exports) in Germany?
Provide a succinct answer. 0.08. What is the difference between the highest and the second highest Exports(as % of merchandise exports) in Netherlands?
Provide a short and direct response. 0.02. What is the difference between the highest and the lowest Exports(as % of merchandise exports) in Argentina?
Offer a terse response. 2.34. What is the difference between the highest and the lowest Exports(as % of merchandise exports) in Czech Republic?
Your response must be concise. 1.2. What is the difference between the highest and the lowest Exports(as % of merchandise exports) in Germany?
Provide a short and direct response. 0.3. What is the difference between the highest and the lowest Exports(as % of merchandise exports) in Netherlands?
Your answer should be very brief. 0.7. 